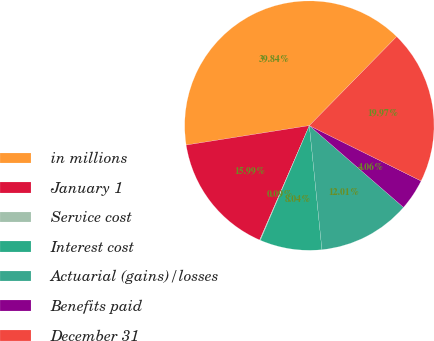Convert chart. <chart><loc_0><loc_0><loc_500><loc_500><pie_chart><fcel>in millions<fcel>January 1<fcel>Service cost<fcel>Interest cost<fcel>Actuarial (gains)/losses<fcel>Benefits paid<fcel>December 31<nl><fcel>39.84%<fcel>15.99%<fcel>0.09%<fcel>8.04%<fcel>12.01%<fcel>4.06%<fcel>19.97%<nl></chart> 